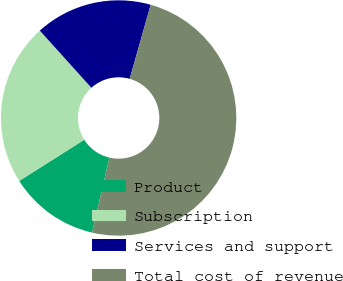Convert chart to OTSL. <chart><loc_0><loc_0><loc_500><loc_500><pie_chart><fcel>Product<fcel>Subscription<fcel>Services and support<fcel>Total cost of revenue<nl><fcel>12.39%<fcel>22.3%<fcel>16.07%<fcel>49.24%<nl></chart> 